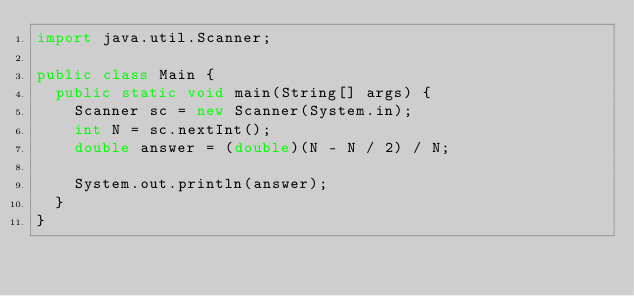Convert code to text. <code><loc_0><loc_0><loc_500><loc_500><_Java_>import java.util.Scanner;

public class Main {
	public static void main(String[] args) {
		Scanner sc = new Scanner(System.in);
		int N = sc.nextInt();
		double answer = (double)(N - N / 2) / N;

		System.out.println(answer);
	}
}
</code> 